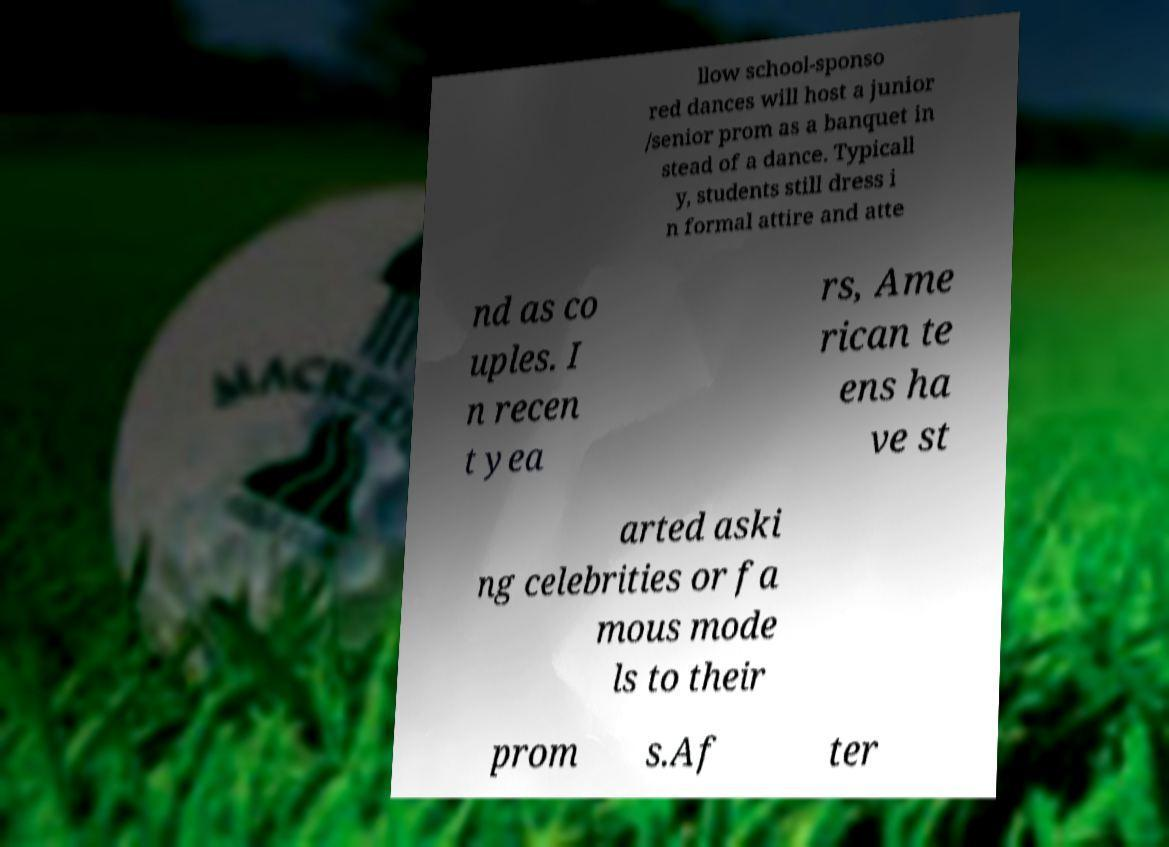For documentation purposes, I need the text within this image transcribed. Could you provide that? llow school-sponso red dances will host a junior /senior prom as a banquet in stead of a dance. Typicall y, students still dress i n formal attire and atte nd as co uples. I n recen t yea rs, Ame rican te ens ha ve st arted aski ng celebrities or fa mous mode ls to their prom s.Af ter 